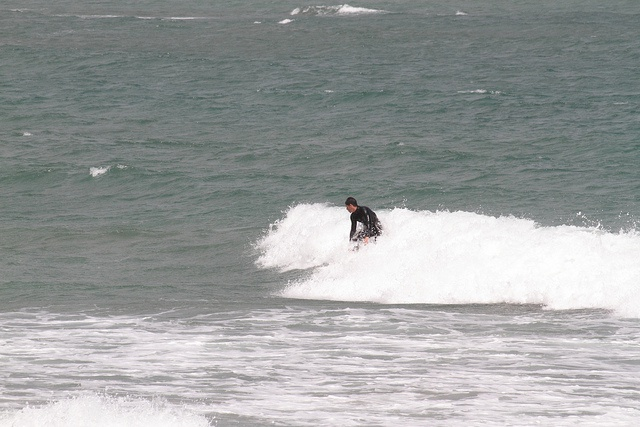Describe the objects in this image and their specific colors. I can see people in gray, black, darkgray, and lightgray tones in this image. 